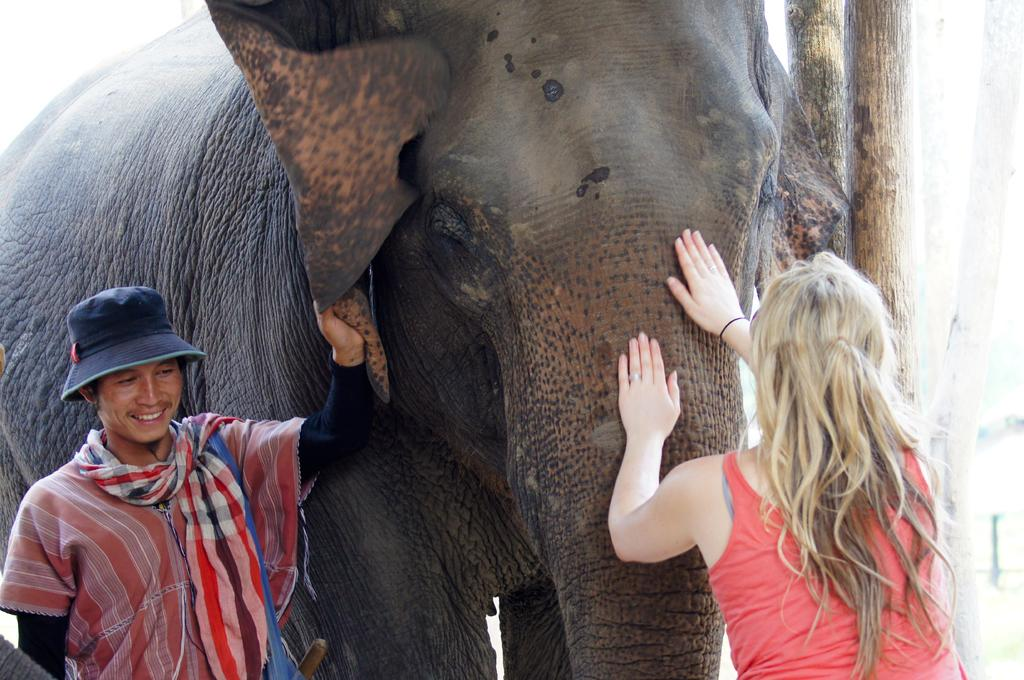What animal is present in the image? There is an elephant in the image. Who is on the left side of the image? There is a man on the left side of the image. What is the man doing with the elephant? The man is holding the ear of the elephant. Who is in front of the elephant? There is a woman in front of the elephant. What is the woman doing with the elephant? The woman is holding the trunk of the elephant. What type of observation can be made about the hospital in the image? There is no hospital present in the image; it features an elephant with a man and a woman interacting with it. What type of bushes can be seen surrounding the elephant in the image? There are no bushes visible in the image; it features an elephant with a man and a woman interacting with it. 